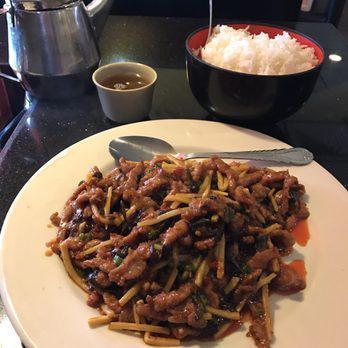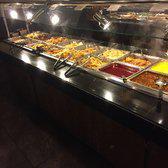The first image is the image on the left, the second image is the image on the right. Analyze the images presented: Is the assertion "All the tongs are black and sliver." valid? Answer yes or no. Yes. The first image is the image on the left, the second image is the image on the right. Analyze the images presented: Is the assertion "The right image shows tongs by rows of steel bins full of food, and the left image includes a white food plate surrounded by other dishware items on a dark table." valid? Answer yes or no. Yes. 